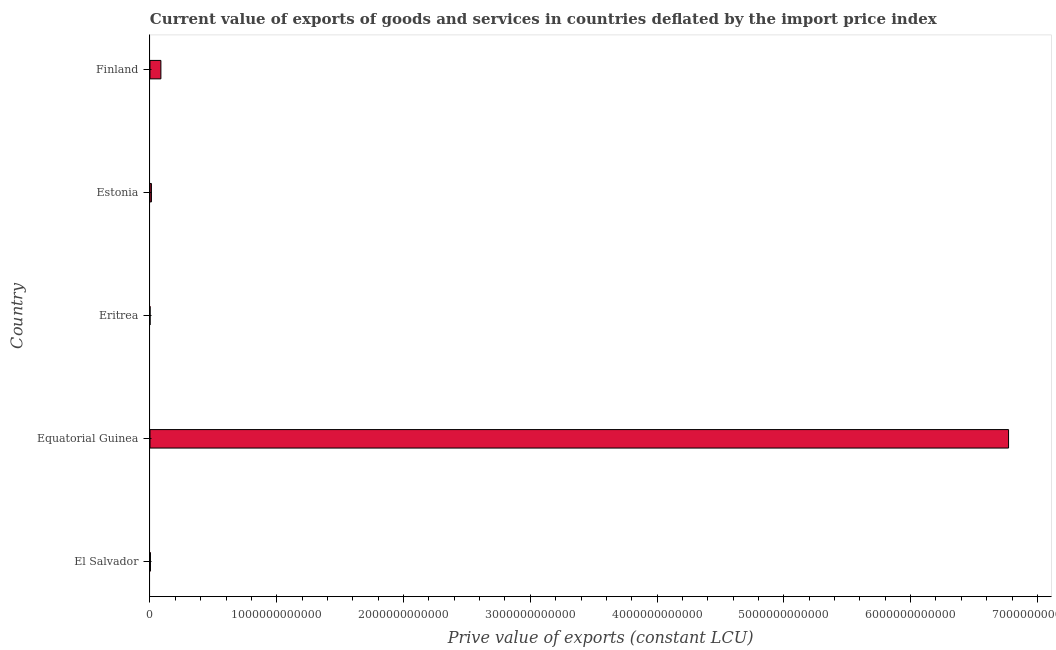Does the graph contain any zero values?
Offer a terse response. No. Does the graph contain grids?
Keep it short and to the point. No. What is the title of the graph?
Give a very brief answer. Current value of exports of goods and services in countries deflated by the import price index. What is the label or title of the X-axis?
Ensure brevity in your answer.  Prive value of exports (constant LCU). What is the label or title of the Y-axis?
Offer a very short reply. Country. What is the price value of exports in El Salvador?
Provide a short and direct response. 3.47e+09. Across all countries, what is the maximum price value of exports?
Provide a short and direct response. 6.77e+12. Across all countries, what is the minimum price value of exports?
Provide a short and direct response. 2.74e+08. In which country was the price value of exports maximum?
Your answer should be very brief. Equatorial Guinea. In which country was the price value of exports minimum?
Give a very brief answer. Eritrea. What is the sum of the price value of exports?
Give a very brief answer. 6.87e+12. What is the difference between the price value of exports in El Salvador and Eritrea?
Give a very brief answer. 3.20e+09. What is the average price value of exports per country?
Your answer should be very brief. 1.37e+12. What is the median price value of exports?
Provide a short and direct response. 1.14e+1. In how many countries, is the price value of exports greater than 4000000000000 LCU?
Offer a very short reply. 1. Is the price value of exports in Equatorial Guinea less than that in Finland?
Give a very brief answer. No. Is the difference between the price value of exports in Eritrea and Estonia greater than the difference between any two countries?
Your response must be concise. No. What is the difference between the highest and the second highest price value of exports?
Keep it short and to the point. 6.69e+12. Is the sum of the price value of exports in Equatorial Guinea and Eritrea greater than the maximum price value of exports across all countries?
Keep it short and to the point. Yes. What is the difference between the highest and the lowest price value of exports?
Ensure brevity in your answer.  6.77e+12. Are all the bars in the graph horizontal?
Make the answer very short. Yes. How many countries are there in the graph?
Offer a very short reply. 5. What is the difference between two consecutive major ticks on the X-axis?
Your response must be concise. 1.00e+12. Are the values on the major ticks of X-axis written in scientific E-notation?
Make the answer very short. No. What is the Prive value of exports (constant LCU) in El Salvador?
Offer a terse response. 3.47e+09. What is the Prive value of exports (constant LCU) of Equatorial Guinea?
Provide a succinct answer. 6.77e+12. What is the Prive value of exports (constant LCU) in Eritrea?
Provide a short and direct response. 2.74e+08. What is the Prive value of exports (constant LCU) in Estonia?
Your answer should be very brief. 1.14e+1. What is the Prive value of exports (constant LCU) in Finland?
Your answer should be compact. 8.60e+1. What is the difference between the Prive value of exports (constant LCU) in El Salvador and Equatorial Guinea?
Your answer should be compact. -6.77e+12. What is the difference between the Prive value of exports (constant LCU) in El Salvador and Eritrea?
Give a very brief answer. 3.20e+09. What is the difference between the Prive value of exports (constant LCU) in El Salvador and Estonia?
Make the answer very short. -7.88e+09. What is the difference between the Prive value of exports (constant LCU) in El Salvador and Finland?
Make the answer very short. -8.25e+1. What is the difference between the Prive value of exports (constant LCU) in Equatorial Guinea and Eritrea?
Provide a succinct answer. 6.77e+12. What is the difference between the Prive value of exports (constant LCU) in Equatorial Guinea and Estonia?
Provide a succinct answer. 6.76e+12. What is the difference between the Prive value of exports (constant LCU) in Equatorial Guinea and Finland?
Give a very brief answer. 6.69e+12. What is the difference between the Prive value of exports (constant LCU) in Eritrea and Estonia?
Provide a short and direct response. -1.11e+1. What is the difference between the Prive value of exports (constant LCU) in Eritrea and Finland?
Give a very brief answer. -8.57e+1. What is the difference between the Prive value of exports (constant LCU) in Estonia and Finland?
Offer a terse response. -7.46e+1. What is the ratio of the Prive value of exports (constant LCU) in El Salvador to that in Equatorial Guinea?
Provide a short and direct response. 0. What is the ratio of the Prive value of exports (constant LCU) in El Salvador to that in Eritrea?
Provide a short and direct response. 12.69. What is the ratio of the Prive value of exports (constant LCU) in El Salvador to that in Estonia?
Your answer should be compact. 0.31. What is the ratio of the Prive value of exports (constant LCU) in Equatorial Guinea to that in Eritrea?
Provide a succinct answer. 2.48e+04. What is the ratio of the Prive value of exports (constant LCU) in Equatorial Guinea to that in Estonia?
Give a very brief answer. 596.42. What is the ratio of the Prive value of exports (constant LCU) in Equatorial Guinea to that in Finland?
Provide a succinct answer. 78.75. What is the ratio of the Prive value of exports (constant LCU) in Eritrea to that in Estonia?
Provide a succinct answer. 0.02. What is the ratio of the Prive value of exports (constant LCU) in Eritrea to that in Finland?
Provide a short and direct response. 0. What is the ratio of the Prive value of exports (constant LCU) in Estonia to that in Finland?
Your response must be concise. 0.13. 